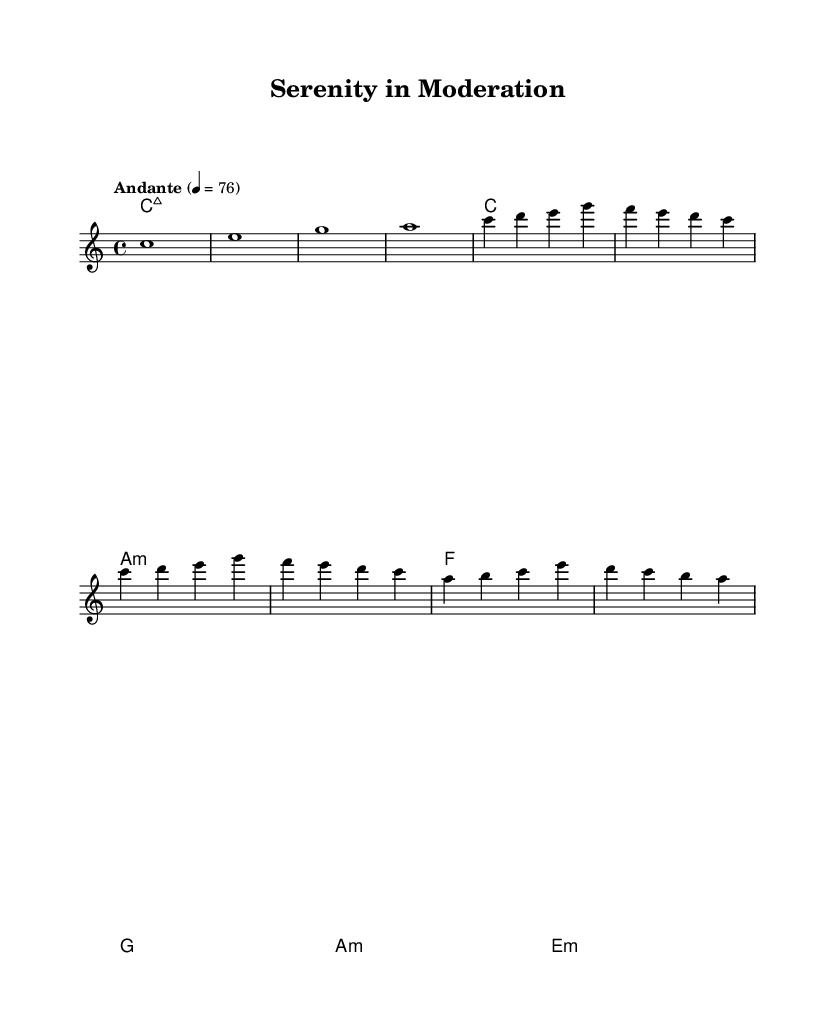What is the key signature of this music? The key signature is C major, which is indicated at the beginning of the score and shows there are no sharps or flats in the staff.
Answer: C major What is the time signature of this music? The time signature is 4/4, shown at the beginning of the score, meaning there are four beats per measure and the quarter note gets one beat.
Answer: 4/4 What is the tempo marking of this piece? The tempo marking "Andante" indicates a moderate pace and is provided at the beginning, along with the metronome marking of 76 beats per minute.
Answer: Andante How many measures are present in the A section? The A section contains a total of 4 measures, which can be counted from the music notation provided in the melody part.
Answer: 4 What chord follows the first measure in this score? The chord indicated in the first measure is a C major seventh chord (Cmaj7), which is shown in the harmonies part at the beginning of the score.
Answer: Cmaj7 How many different chords are used in the B section? The B section features two different chords (A minor and E minor), which can be deduced from the chord markings present in the harmonies for that section.
Answer: 2 What is the primary emotion conveyed through the harmonic structure of this piece? The harmonic structure uses major and minor chords, suggesting a blend of serene and contemplative emotions, characteristic of Romantic music, especially in its soft ambient style.
Answer: Serene 